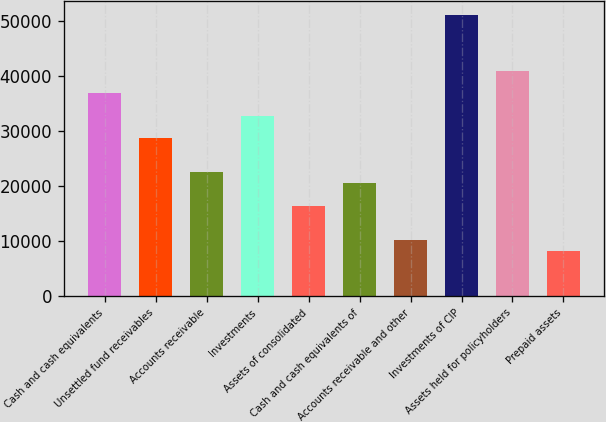Convert chart. <chart><loc_0><loc_0><loc_500><loc_500><bar_chart><fcel>Cash and cash equivalents<fcel>Unsettled fund receivables<fcel>Accounts receivable<fcel>Investments<fcel>Assets of consolidated<fcel>Cash and cash equivalents of<fcel>Accounts receivable and other<fcel>Investments of CIP<fcel>Assets held for policyholders<fcel>Prepaid assets<nl><fcel>36818.4<fcel>28640.5<fcel>22507<fcel>32729.4<fcel>16373.5<fcel>20462.5<fcel>10240<fcel>51129.8<fcel>40907.4<fcel>8195.56<nl></chart> 